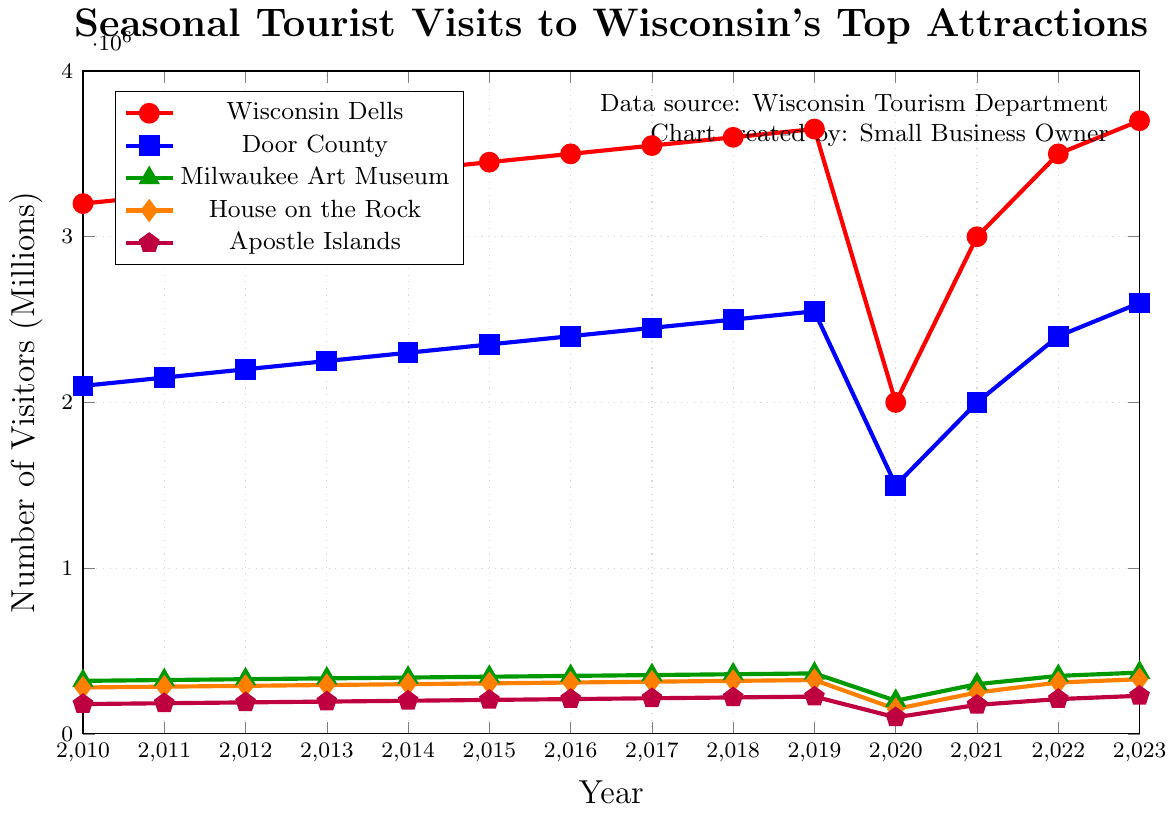What's the general trend of tourist visits to the Wisconsin Dells from 2010 to 2023? The figure shows a line with points indicating tourist visits to the Wisconsin Dells from each year between 2010 and 2023. Except for the dip in 2020, there is a generally increasing trend in the number of visitors over the years.
Answer: Increasing trend In which year did the Milwaukee Art Museum see the lowest number of tourists? Referring to the green line with triangle markers, the lowest point on the line appears in the year 2020.
Answer: 2020 By how much did the number of visitors to Door County change between 2019 and 2020? In 2019, Door County had 2,550,000 visitors, and in 2020, it had 1,500,000 visitors. The change in number of visitors is calculated as 2,550,000 - 1,500,000.
Answer: 1,050,000 Which attraction showed the sharpest decline in visitors in 2020 compared to 2019? To identify the sharpest decline, we look at the visual drop in each line from 2019 to 2020. Wisconsin Dells has the most significant decrease from 3,650,000 to 2,000,000 visitors.
Answer: Wisconsin Dells Comparing 2022 to 2023, which attraction showed the greatest increase in the number of visitors? By observing the lines between 2022 and 2023, Wisconsin Dells increased from 3,500,000 to 3,700,000 visitors, an increase of 200,000. This represents the greatest increase among all attractions.
Answer: Wisconsin Dells Which attraction had the fewest visitors in 2013 and how many were there? By locating the point for 2013 across all the lines, we see that the purple line with pentagon markers for the Apostle Islands is lowest, with 195,000 visitors.
Answer: Apostle Islands, 195,000 What is the average number of visitors to the Milwaukee Art Museum from 2010 to 2019 inclusive? Sum up the visitors from 2010 to 2019: (320,000 + 325,000 + 330,000 + 335,000 + 340,000 + 345,000 + 350,000 + 355,000 + 360,000 + 365,000) = 3,725,000. Divide by 10 to get the average.
Answer: 372,500 What was the combined number of visitors to all attractions in 2021? Summing up the visitors for 2021: 3,000,000 (Wisconsin Dells) + 2,000,000 (Door County) + 300,000 (Milwaukee Art Museum) + 250,000 (House on the Rock) + 175,000 (Apostle Islands) = 5,725,000.
Answer: 5,725,000 In what year did House on the Rock first surpass 300,000 visitors? Looking at the orange line with diamond markers, House on the Rock first has more than 300,000 visitors in 2014.
Answer: 2014 